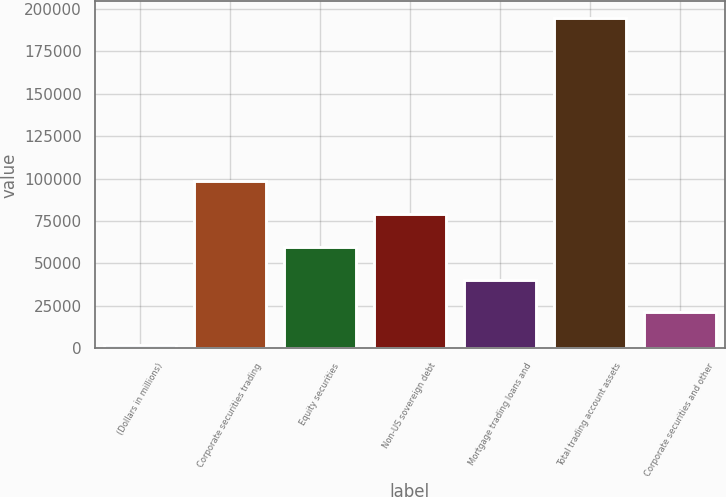<chart> <loc_0><loc_0><loc_500><loc_500><bar_chart><fcel>(Dollars in millions)<fcel>Corporate securities trading<fcel>Equity securities<fcel>Non-US sovereign debt<fcel>Mortgage trading loans and<fcel>Total trading account assets<fcel>Corporate securities and other<nl><fcel>2010<fcel>98340.5<fcel>59808.3<fcel>79074.4<fcel>40542.2<fcel>194671<fcel>21276.1<nl></chart> 